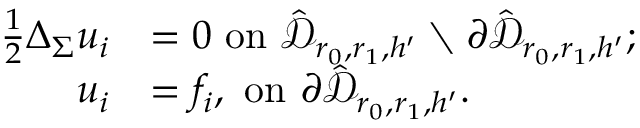<formula> <loc_0><loc_0><loc_500><loc_500>\begin{array} { r l } { \frac { 1 } { 2 } \Delta _ { \Sigma } u _ { i } } & { = 0 o n \hat { \mathcal { D } } _ { r _ { 0 } , r _ { 1 } , h ^ { \prime } } \ \partial \hat { \mathcal { D } } _ { r _ { 0 } , r _ { 1 } , h ^ { \prime } } ; } \\ { u _ { i } } & { = f _ { i } , o n \partial \hat { \mathcal { D } } _ { r _ { 0 } , r _ { 1 } , h ^ { \prime } } . } \end{array}</formula> 